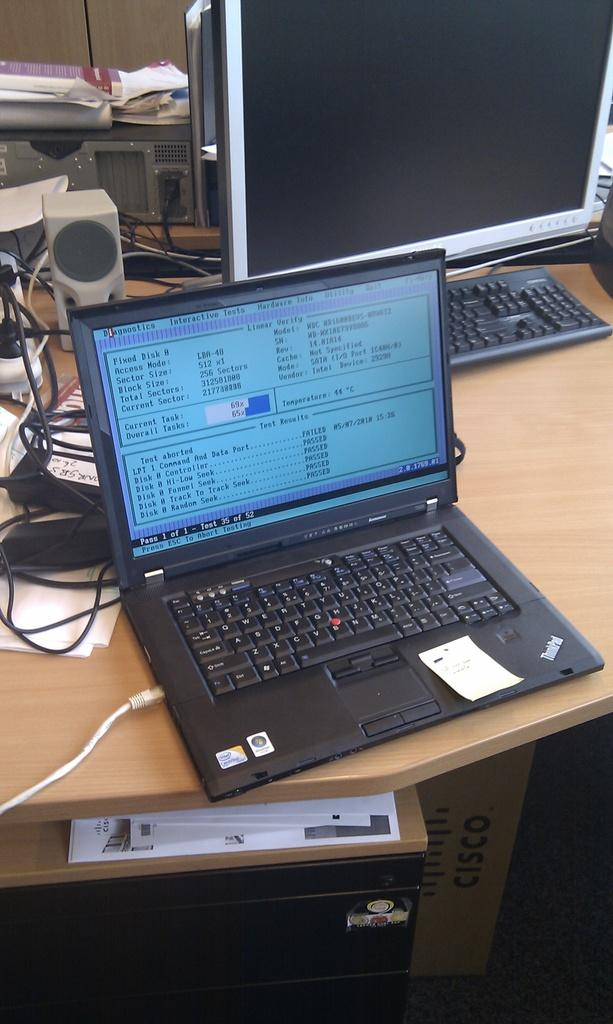<image>
Present a compact description of the photo's key features. a laptop is open and has diagnostics on it 